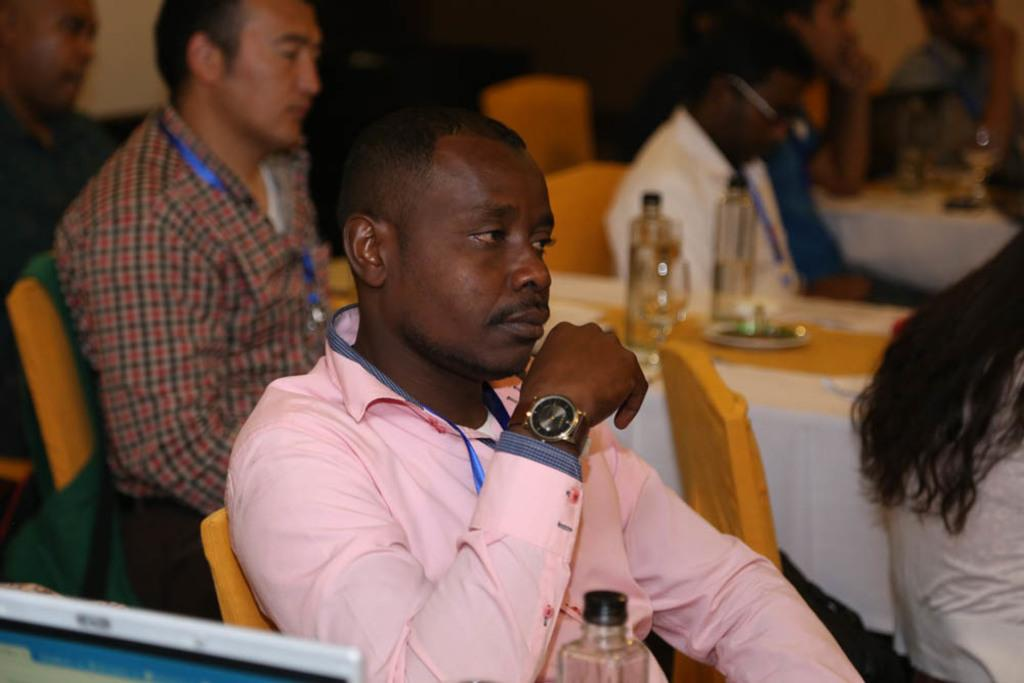What are the people in the image doing? The persons in the image are sitting on chairs in front of a table. What is on the table? There is a plate and bottles on the table. Can you describe the attire of one of the persons? The person in the pink dress is wearing a watch. What type of pin can be seen holding the space shuttle together in the image? There is no space shuttle or pin present in the image. 